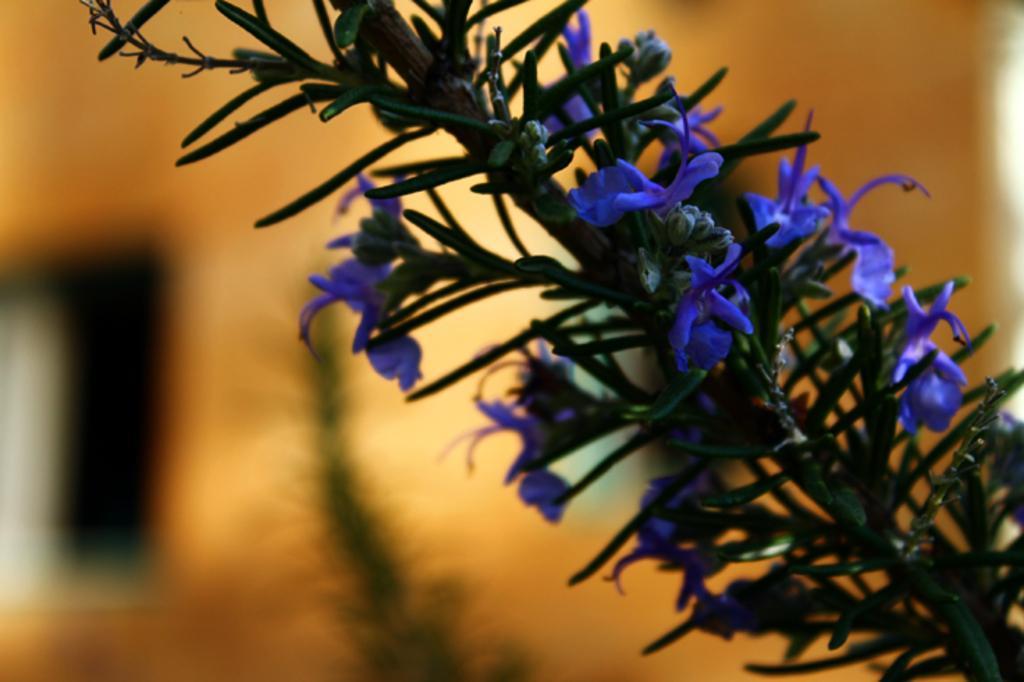Please provide a concise description of this image. In this image in the foreground there is a plant and some flowers and in the background there is some plant, wall and the background is blurred. 